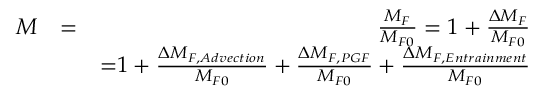Convert formula to latex. <formula><loc_0><loc_0><loc_500><loc_500>\begin{array} { r l r } { M } & { = } & { \frac { M _ { F } } { M _ { F 0 } } = 1 + \frac { \Delta M _ { F } } { M _ { F 0 } } } \\ & { \mathrm = 1 + \frac { \Delta M _ { F , A d v e c t i o n } } { M _ { F 0 } } + \frac { \Delta M _ { F , P G F } } { M _ { F 0 } } + \frac { \Delta M _ { F , E n t r a i n m e n t } } { M _ { F 0 } } } \end{array}</formula> 